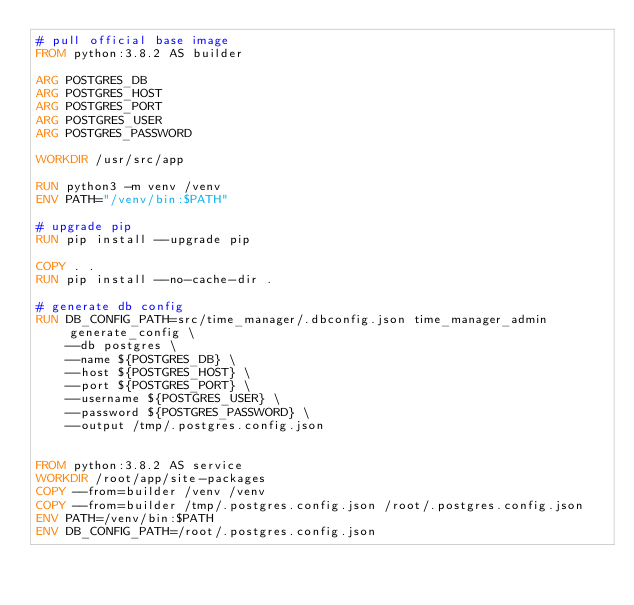Convert code to text. <code><loc_0><loc_0><loc_500><loc_500><_Dockerfile_># pull official base image
FROM python:3.8.2 AS builder

ARG POSTGRES_DB
ARG POSTGRES_HOST
ARG POSTGRES_PORT
ARG POSTGRES_USER
ARG POSTGRES_PASSWORD

WORKDIR /usr/src/app

RUN python3 -m venv /venv
ENV PATH="/venv/bin:$PATH"

# upgrade pip
RUN pip install --upgrade pip

COPY . .
RUN pip install --no-cache-dir .

# generate db config
RUN DB_CONFIG_PATH=src/time_manager/.dbconfig.json time_manager_admin generate_config \
    --db postgres \
    --name ${POSTGRES_DB} \
    --host ${POSTGRES_HOST} \
    --port ${POSTGRES_PORT} \
    --username ${POSTGRES_USER} \
    --password ${POSTGRES_PASSWORD} \
    --output /tmp/.postgres.config.json


FROM python:3.8.2 AS service
WORKDIR /root/app/site-packages
COPY --from=builder /venv /venv
COPY --from=builder /tmp/.postgres.config.json /root/.postgres.config.json
ENV PATH=/venv/bin:$PATH
ENV DB_CONFIG_PATH=/root/.postgres.config.json
</code> 